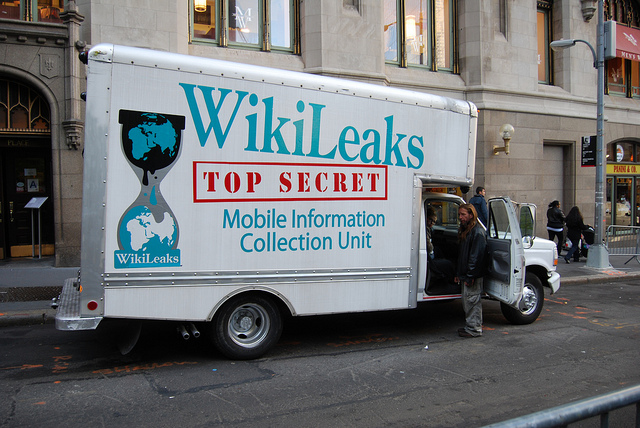Identify and read out the text in this image. WikiLeaks TOP SECRET Mobil Information Unit Collection 